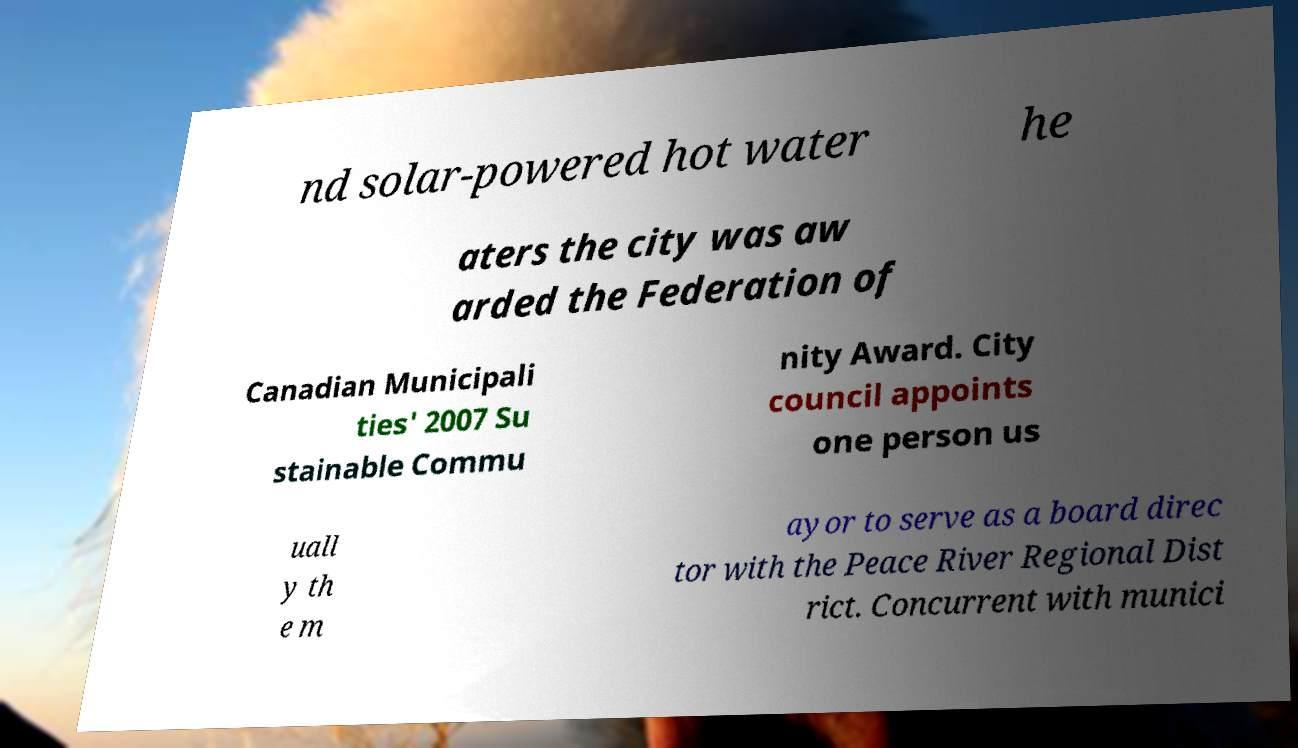Can you read and provide the text displayed in the image?This photo seems to have some interesting text. Can you extract and type it out for me? nd solar-powered hot water he aters the city was aw arded the Federation of Canadian Municipali ties' 2007 Su stainable Commu nity Award. City council appoints one person us uall y th e m ayor to serve as a board direc tor with the Peace River Regional Dist rict. Concurrent with munici 